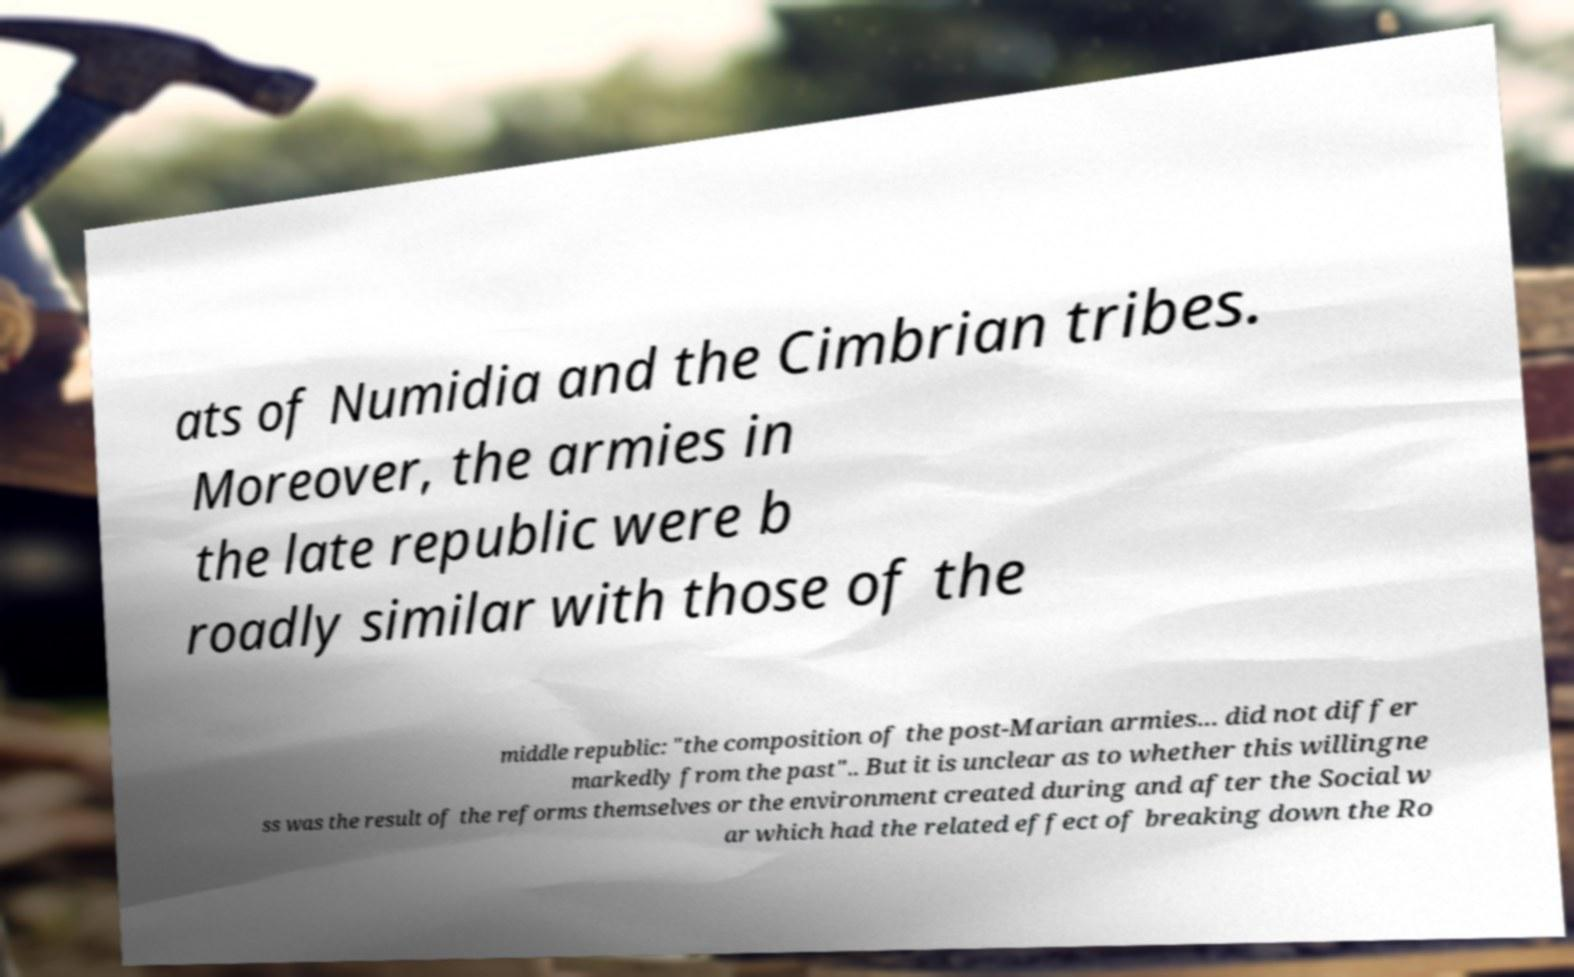Please identify and transcribe the text found in this image. ats of Numidia and the Cimbrian tribes. Moreover, the armies in the late republic were b roadly similar with those of the middle republic: "the composition of the post-Marian armies... did not differ markedly from the past".. But it is unclear as to whether this willingne ss was the result of the reforms themselves or the environment created during and after the Social w ar which had the related effect of breaking down the Ro 